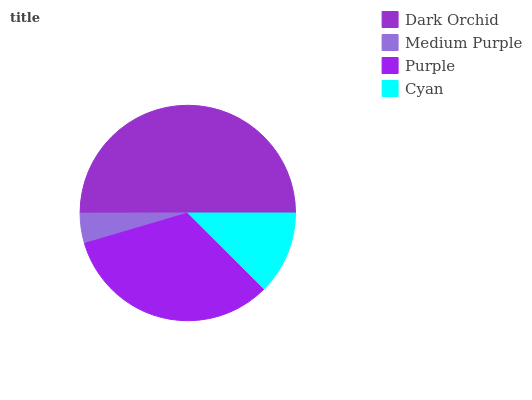Is Medium Purple the minimum?
Answer yes or no. Yes. Is Dark Orchid the maximum?
Answer yes or no. Yes. Is Purple the minimum?
Answer yes or no. No. Is Purple the maximum?
Answer yes or no. No. Is Purple greater than Medium Purple?
Answer yes or no. Yes. Is Medium Purple less than Purple?
Answer yes or no. Yes. Is Medium Purple greater than Purple?
Answer yes or no. No. Is Purple less than Medium Purple?
Answer yes or no. No. Is Purple the high median?
Answer yes or no. Yes. Is Cyan the low median?
Answer yes or no. Yes. Is Dark Orchid the high median?
Answer yes or no. No. Is Purple the low median?
Answer yes or no. No. 